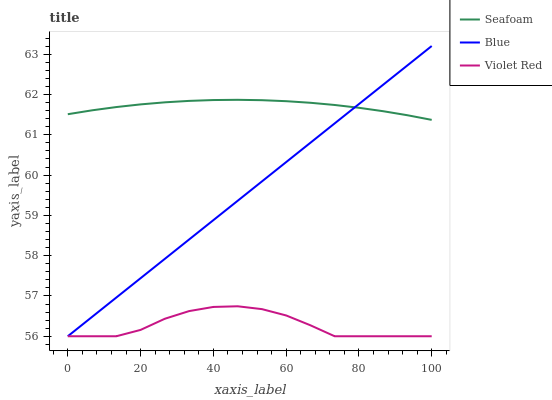Does Seafoam have the minimum area under the curve?
Answer yes or no. No. Does Violet Red have the maximum area under the curve?
Answer yes or no. No. Is Seafoam the smoothest?
Answer yes or no. No. Is Seafoam the roughest?
Answer yes or no. No. Does Seafoam have the lowest value?
Answer yes or no. No. Does Seafoam have the highest value?
Answer yes or no. No. Is Violet Red less than Seafoam?
Answer yes or no. Yes. Is Seafoam greater than Violet Red?
Answer yes or no. Yes. Does Violet Red intersect Seafoam?
Answer yes or no. No. 